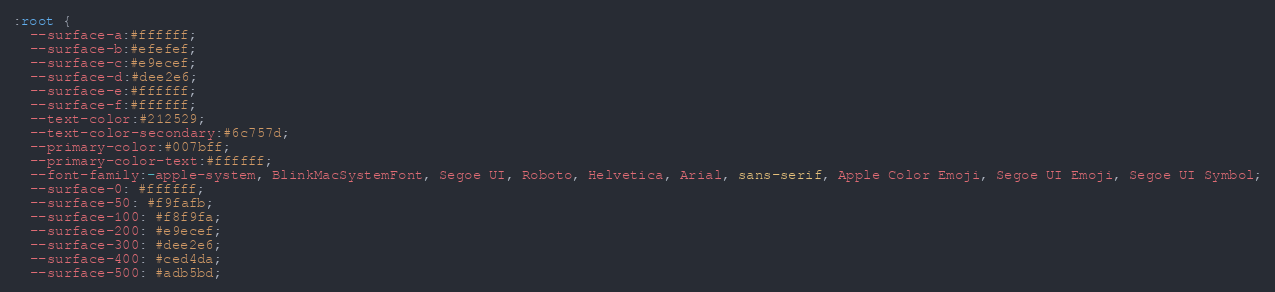<code> <loc_0><loc_0><loc_500><loc_500><_CSS_>:root {
  --surface-a:#ffffff;
  --surface-b:#efefef;
  --surface-c:#e9ecef;
  --surface-d:#dee2e6;
  --surface-e:#ffffff;
  --surface-f:#ffffff;
  --text-color:#212529;
  --text-color-secondary:#6c757d;
  --primary-color:#007bff;
  --primary-color-text:#ffffff;
  --font-family:-apple-system, BlinkMacSystemFont, Segoe UI, Roboto, Helvetica, Arial, sans-serif, Apple Color Emoji, Segoe UI Emoji, Segoe UI Symbol;
  --surface-0: #ffffff;
  --surface-50: #f9fafb;
  --surface-100: #f8f9fa;
  --surface-200: #e9ecef;
  --surface-300: #dee2e6;
  --surface-400: #ced4da;
  --surface-500: #adb5bd;</code> 